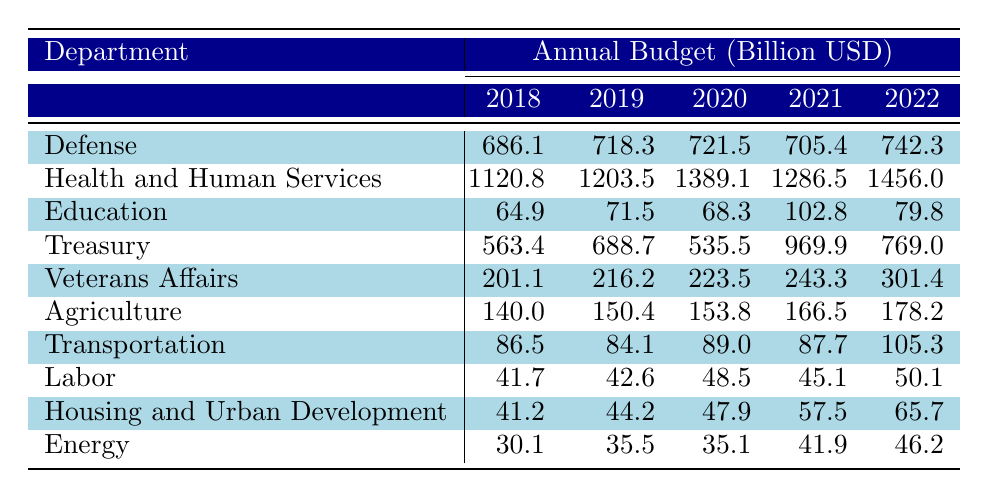What is the budget of the Department of Health and Human Services in 2022? The budget for the Department of Health and Human Services in 2022 can be found in the table under the 2022 column for that department, which shows a value of 1456.0 billion USD.
Answer: 1456.0 billion USD Which department had the highest budget in 2019? By comparing the budget values in the 2019 column for all departments, the Department of Health and Human Services has the highest budget with 1203.5 billion USD.
Answer: Department of Health and Human Services What was the average budget for the Department of Education over the years? To find the average, sum the values for the Department of Education over all years: (64.9 + 71.5 + 68.3 + 102.8 + 79.8) = 387.3. Then divide by the number of years (5): 387.3 / 5 = 77.46.
Answer: 77.46 billion USD Did the budget for the Department of Transportation increase or decrease from 2018 to 2022? In 2018, the budget was 86.5 billion USD, and in 2022, it was 105.3 billion USD. Since 105.3 is greater than 86.5, the budget increased.
Answer: Increased What is the total budget allocated to the Department of Veterans Affairs and Department of Agriculture in 2021? To find the total budget for 2021, add the budgets for both departments in that year: Department of Veterans Affairs (243.3) + Department of Agriculture (166.5) = 409.8 billion USD.
Answer: 409.8 billion USD Which department had the smallest budget increase from 2018 to 2022? Calculate the budget increase for each department from 2018 to 2022. For Education, the increase is 79.8 - 64.9 = 14.9 billion USD. The smallest increase is for the Department of Transportation, which increased by only 105.3 - 86.5 = 18.8 billion USD.
Answer: Department of Education What was the budget allocation change for the Department of Treasury from 2020 to 2021? The budget for the Department of Treasury in 2020 was 535.5 billion USD and in 2021 it was 969.9 billion USD. The change is 969.9 - 535.5 = 434.4 billion USD, indicating a significant increase.
Answer: 434.4 billion USD increase How much more did the Department of Veterans Affairs receive compared to the Department of Labor in 2021? In 2021, the budget for Veterans Affairs was 243.3 billion USD and for Labor, it was 45.1 billion USD. The difference is 243.3 - 45.1 = 198.2 billion USD.
Answer: 198.2 billion USD In which year did the Department of Education see the largest budget value? By observing the budgets for the Department of Education across all years, the highest value is in 2021, where it was 102.8 billion USD.
Answer: 2021 Is the budget for the Department of Energy consistent over the years? Looking at the budget values for the Department of Energy across the years, they are 30.1, 35.5, 35.1, 41.9, and 46.2 billion USD. This shows a general upward trend; hence, it cannot be considered consistent.
Answer: No, it is not consistent 